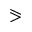<formula> <loc_0><loc_0><loc_500><loc_500>\ e q s l a n t g t r</formula> 